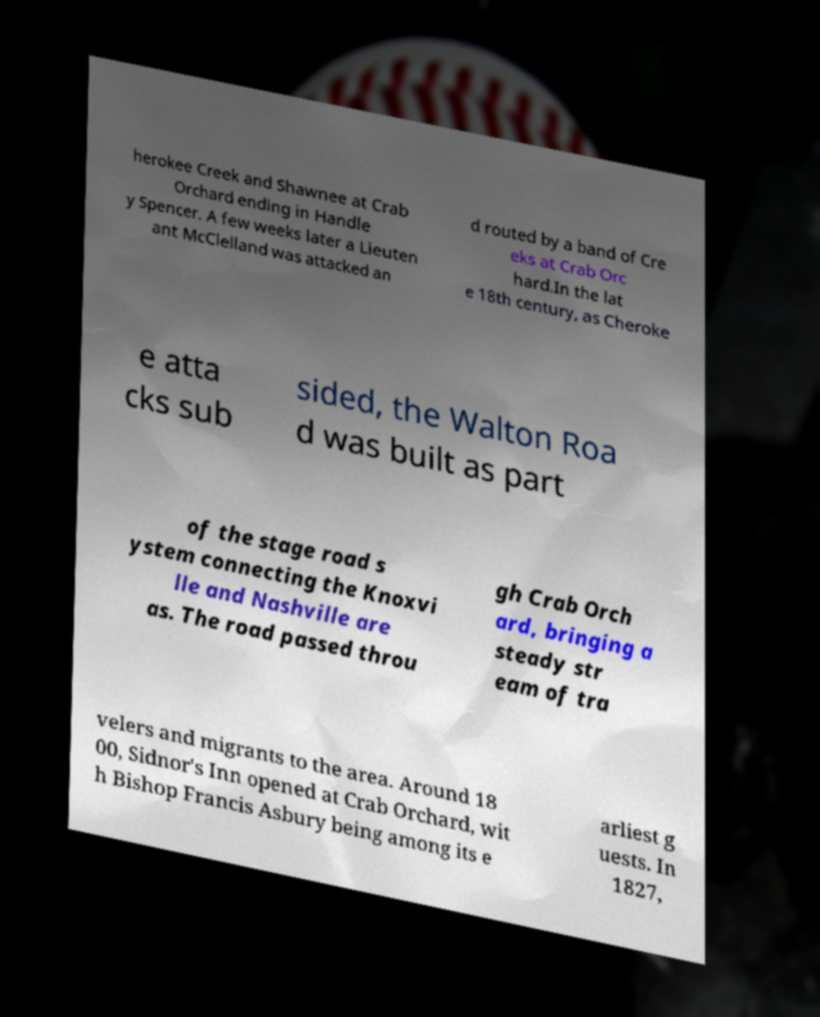Could you assist in decoding the text presented in this image and type it out clearly? herokee Creek and Shawnee at Crab Orchard ending in Handle y Spencer. A few weeks later a Lieuten ant McClelland was attacked an d routed by a band of Cre eks at Crab Orc hard.In the lat e 18th century, as Cheroke e atta cks sub sided, the Walton Roa d was built as part of the stage road s ystem connecting the Knoxvi lle and Nashville are as. The road passed throu gh Crab Orch ard, bringing a steady str eam of tra velers and migrants to the area. Around 18 00, Sidnor's Inn opened at Crab Orchard, wit h Bishop Francis Asbury being among its e arliest g uests. In 1827, 